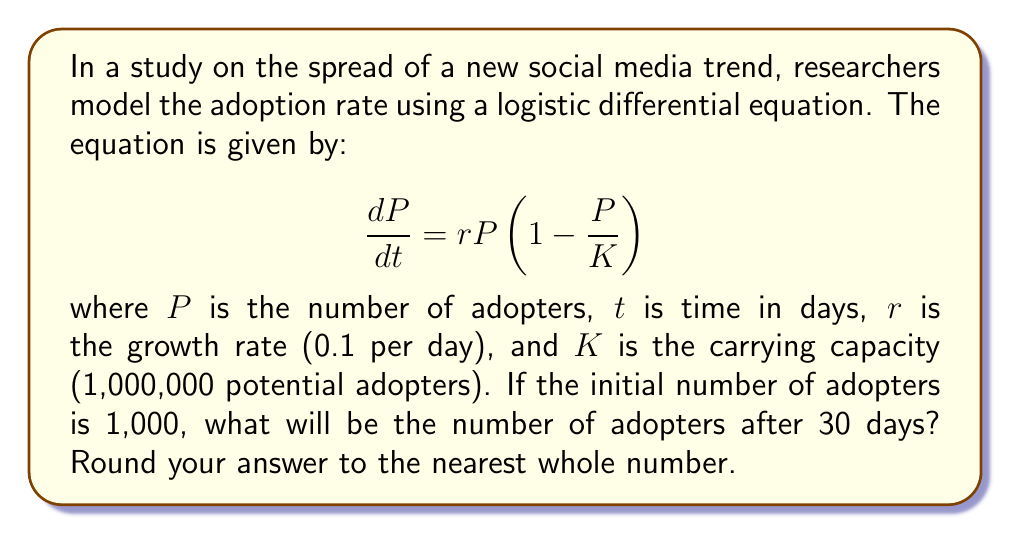Give your solution to this math problem. To solve this problem, we need to use the analytical solution of the logistic differential equation:

$$P(t) = \frac{K}{1 + (\frac{K}{P_0} - 1)e^{-rt}}$$

Where:
- $K$ is the carrying capacity (1,000,000)
- $P_0$ is the initial number of adopters (1,000)
- $r$ is the growth rate (0.1 per day)
- $t$ is the time in days (30)

Let's substitute these values into the equation:

$$P(30) = \frac{1,000,000}{1 + (\frac{1,000,000}{1,000} - 1)e^{-0.1 \times 30}}$$

$$= \frac{1,000,000}{1 + (999)e^{-3}}$$

Now, let's calculate this step-by-step:

1. Calculate $e^{-3}$:
   $e^{-3} \approx 0.0497$

2. Multiply by 999:
   $999 \times 0.0497 \approx 49.6503$

3. Add 1:
   $1 + 49.6503 = 50.6503$

4. Divide 1,000,000 by this result:
   $\frac{1,000,000}{50.6503} \approx 19,743.8$

5. Round to the nearest whole number:
   19,744

Therefore, after 30 days, there will be approximately 19,744 adopters of the social media trend.
Answer: 19,744 adopters 